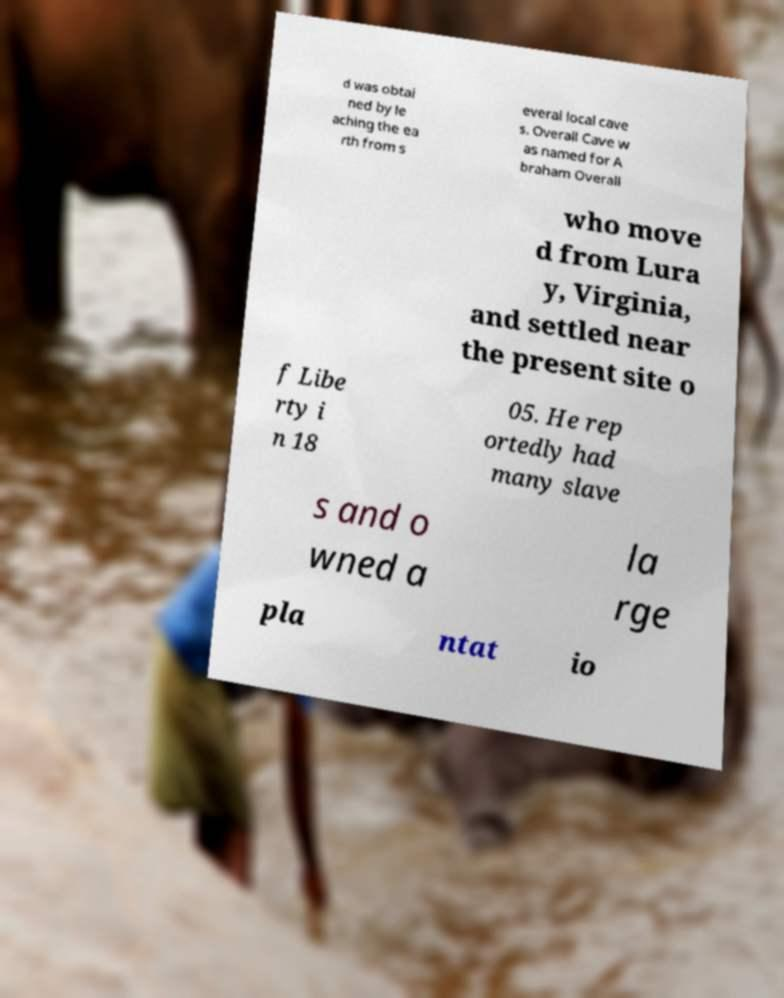Please identify and transcribe the text found in this image. d was obtai ned by le aching the ea rth from s everal local cave s. Overall Cave w as named for A braham Overall who move d from Lura y, Virginia, and settled near the present site o f Libe rty i n 18 05. He rep ortedly had many slave s and o wned a la rge pla ntat io 